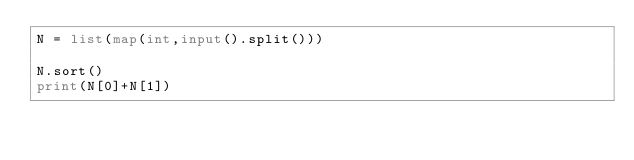<code> <loc_0><loc_0><loc_500><loc_500><_Python_>N = list(map(int,input().split()))

N.sort()
print(N[0]+N[1])</code> 